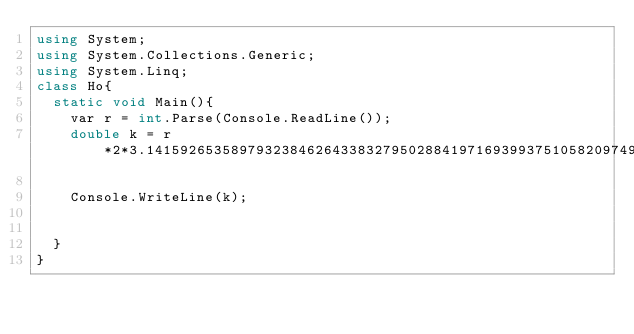Convert code to text. <code><loc_0><loc_0><loc_500><loc_500><_C#_>using System;
using System.Collections.Generic;
using System.Linq;
class Ho{
  static void Main(){
    var r = int.Parse(Console.ReadLine());
    double k = r*2*3.141592653589793238462643383279502884197169399375105820974944592307816406286208998628034825342117067;

    Console.WriteLine(k);
    
   
  }
}</code> 